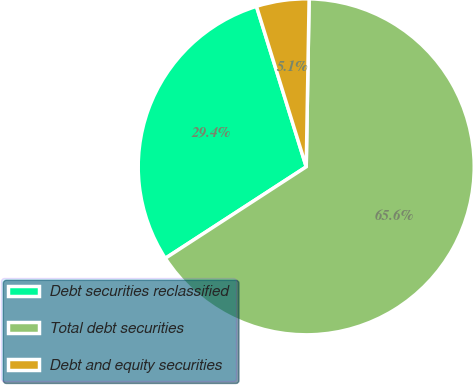<chart> <loc_0><loc_0><loc_500><loc_500><pie_chart><fcel>Debt securities reclassified<fcel>Total debt securities<fcel>Debt and equity securities<nl><fcel>29.38%<fcel>65.56%<fcel>5.06%<nl></chart> 